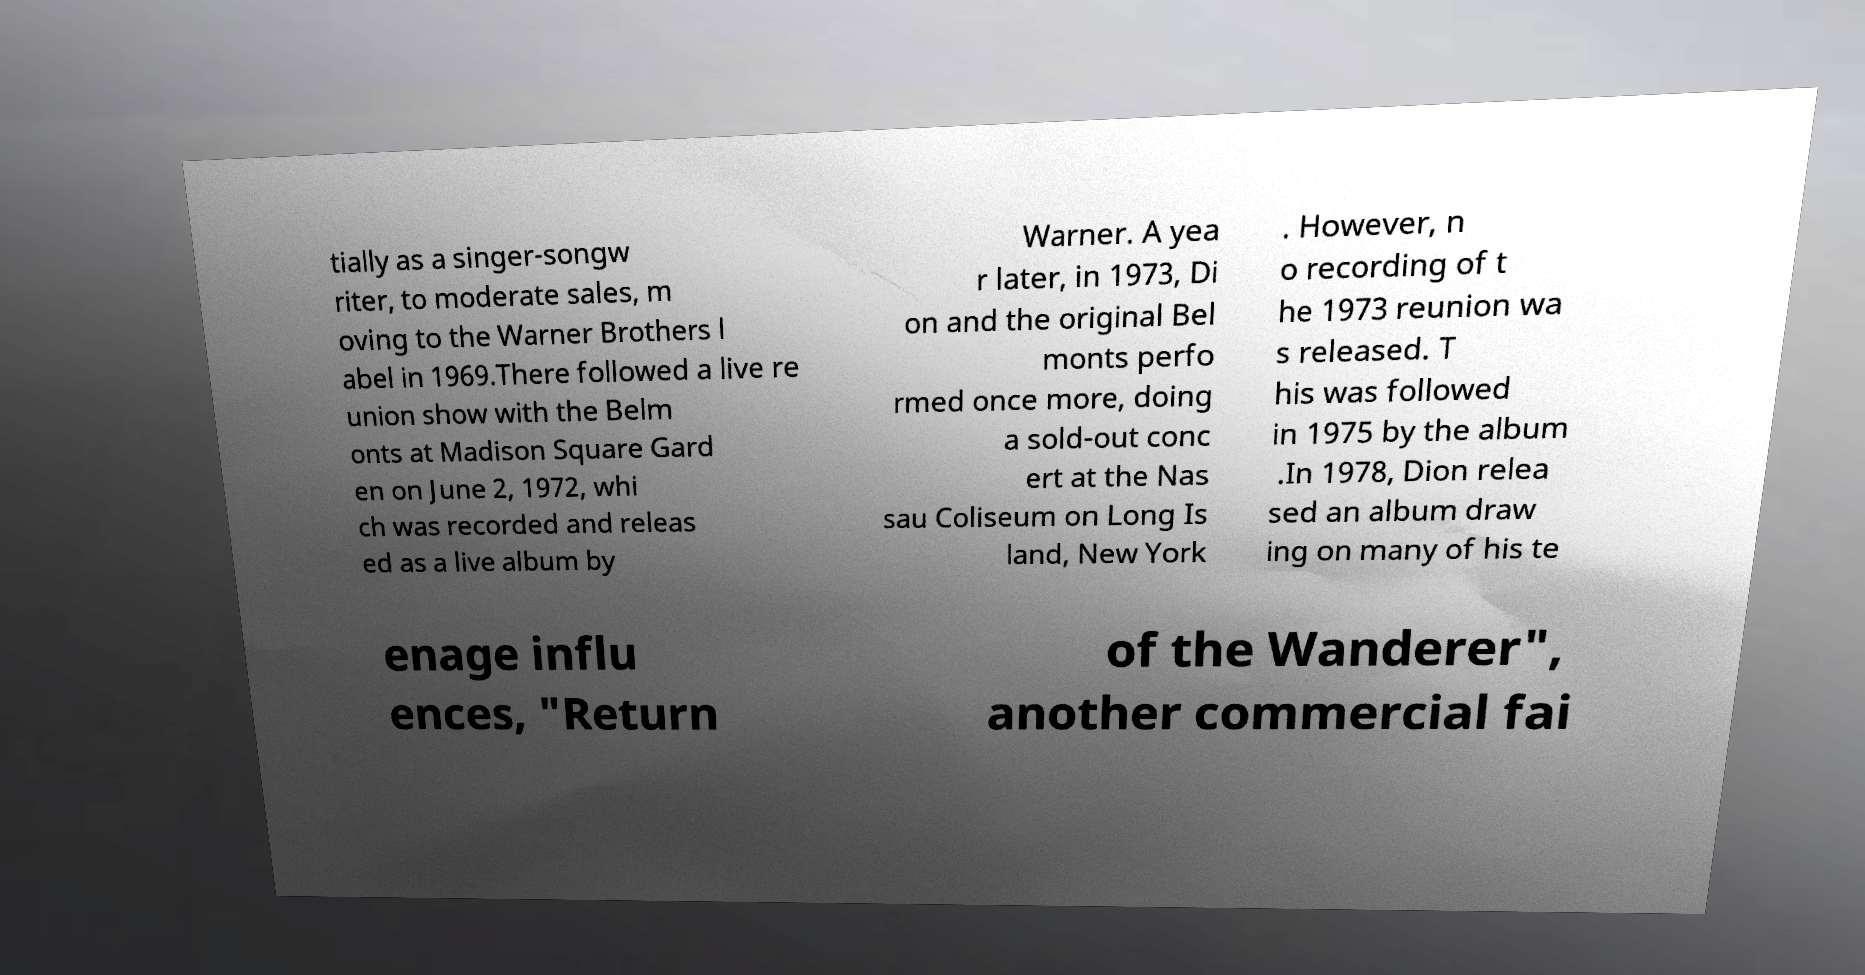There's text embedded in this image that I need extracted. Can you transcribe it verbatim? tially as a singer-songw riter, to moderate sales, m oving to the Warner Brothers l abel in 1969.There followed a live re union show with the Belm onts at Madison Square Gard en on June 2, 1972, whi ch was recorded and releas ed as a live album by Warner. A yea r later, in 1973, Di on and the original Bel monts perfo rmed once more, doing a sold-out conc ert at the Nas sau Coliseum on Long Is land, New York . However, n o recording of t he 1973 reunion wa s released. T his was followed in 1975 by the album .In 1978, Dion relea sed an album draw ing on many of his te enage influ ences, "Return of the Wanderer", another commercial fai 